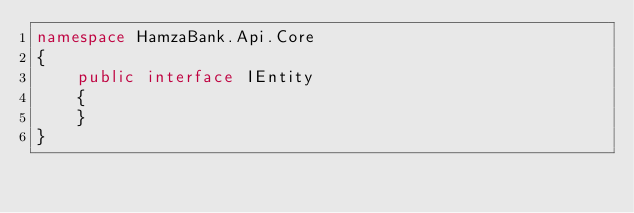Convert code to text. <code><loc_0><loc_0><loc_500><loc_500><_C#_>namespace HamzaBank.Api.Core
{
    public interface IEntity
    {
    }
}</code> 